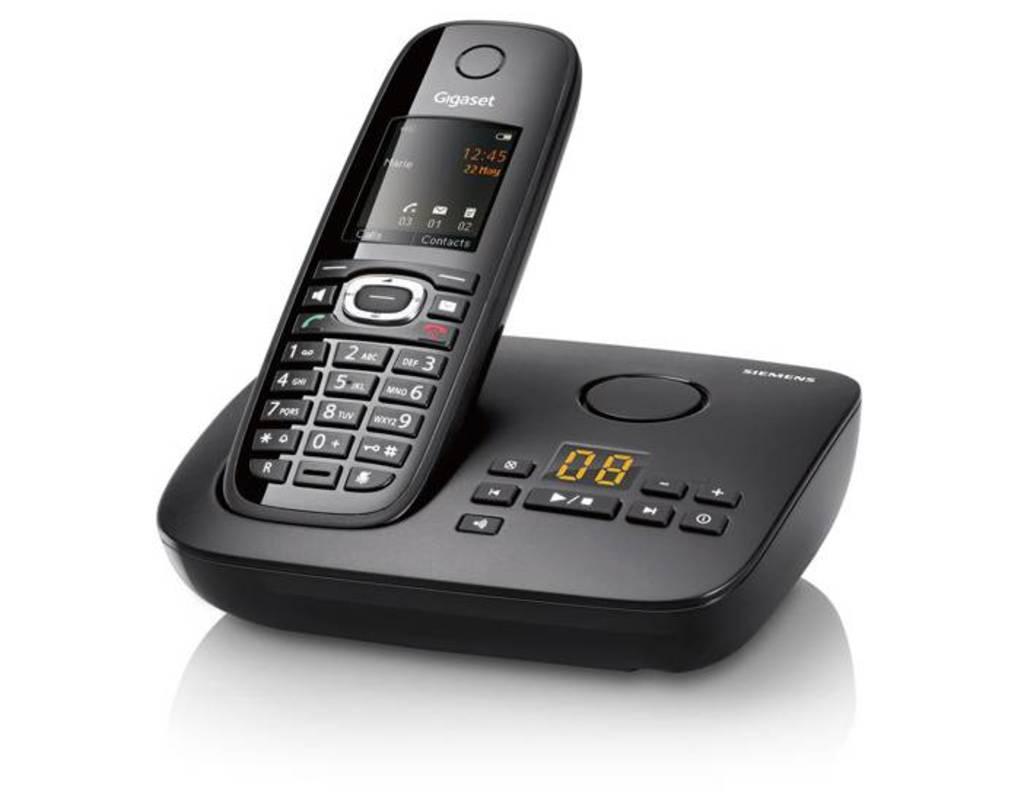How many voicemails are on the answering machine?
Provide a succinct answer. 8. 